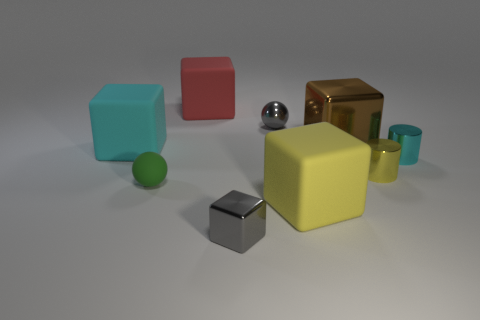How many brown objects are shiny objects or small metallic cubes?
Your response must be concise. 1. Are there an equal number of large cyan matte blocks that are behind the big red cube and tiny yellow metallic cylinders in front of the tiny matte object?
Offer a terse response. Yes. What color is the tiny metal block in front of the tiny sphere left of the rubber object behind the shiny ball?
Your answer should be compact. Gray. Is there anything else that has the same color as the tiny rubber sphere?
Provide a succinct answer. No. There is a shiny object that is the same color as the metallic ball; what is its shape?
Provide a short and direct response. Cube. What is the size of the cyan object left of the small gray metallic sphere?
Keep it short and to the point. Large. There is a yellow metallic object that is the same size as the cyan metal thing; what shape is it?
Offer a terse response. Cylinder. Are the small object on the right side of the small yellow thing and the big cube that is behind the brown object made of the same material?
Ensure brevity in your answer.  No. There is a block that is behind the tiny gray thing behind the small cyan cylinder; what is its material?
Offer a very short reply. Rubber. What size is the cylinder that is in front of the tiny cylinder behind the tiny metal cylinder that is in front of the tiny cyan metallic object?
Give a very brief answer. Small. 